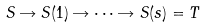Convert formula to latex. <formula><loc_0><loc_0><loc_500><loc_500>S \rightarrow S ( 1 ) \rightarrow \cdots \rightarrow S ( s ) = T</formula> 